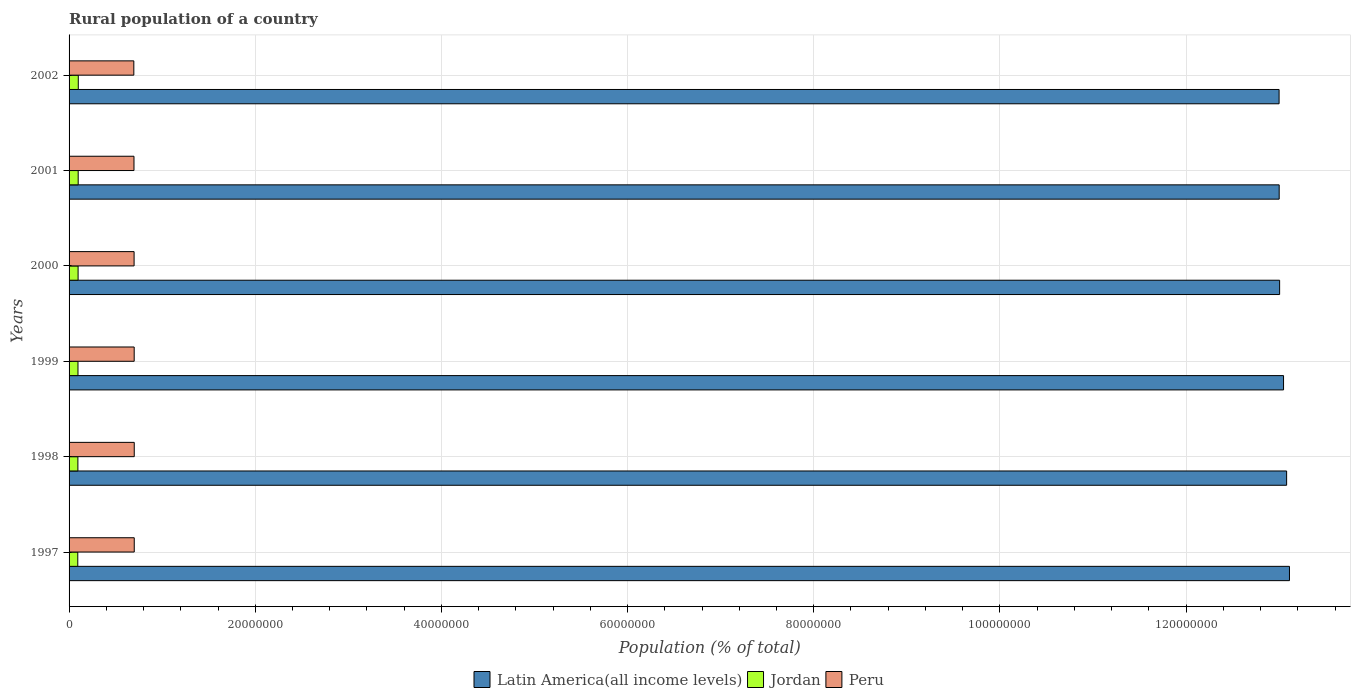How many different coloured bars are there?
Give a very brief answer. 3. How many groups of bars are there?
Make the answer very short. 6. Are the number of bars per tick equal to the number of legend labels?
Provide a short and direct response. Yes. Are the number of bars on each tick of the Y-axis equal?
Your response must be concise. Yes. How many bars are there on the 4th tick from the top?
Give a very brief answer. 3. What is the label of the 1st group of bars from the top?
Offer a very short reply. 2002. What is the rural population in Latin America(all income levels) in 1998?
Your answer should be very brief. 1.31e+08. Across all years, what is the maximum rural population in Jordan?
Provide a short and direct response. 9.89e+05. Across all years, what is the minimum rural population in Jordan?
Your answer should be compact. 9.35e+05. In which year was the rural population in Jordan maximum?
Provide a short and direct response. 2002. What is the total rural population in Peru in the graph?
Your answer should be compact. 4.19e+07. What is the difference between the rural population in Peru in 1997 and that in 2002?
Ensure brevity in your answer.  4.55e+04. What is the difference between the rural population in Jordan in 2000 and the rural population in Latin America(all income levels) in 1999?
Your answer should be very brief. -1.30e+08. What is the average rural population in Peru per year?
Ensure brevity in your answer.  6.99e+06. In the year 1998, what is the difference between the rural population in Peru and rural population in Jordan?
Provide a short and direct response. 6.05e+06. What is the ratio of the rural population in Peru in 1998 to that in 1999?
Keep it short and to the point. 1. Is the rural population in Peru in 1999 less than that in 2000?
Your answer should be compact. No. Is the difference between the rural population in Peru in 2001 and 2002 greater than the difference between the rural population in Jordan in 2001 and 2002?
Provide a succinct answer. Yes. What is the difference between the highest and the second highest rural population in Peru?
Provide a short and direct response. 329. What is the difference between the highest and the lowest rural population in Jordan?
Keep it short and to the point. 5.38e+04. What does the 3rd bar from the top in 2000 represents?
Offer a very short reply. Latin America(all income levels). What does the 2nd bar from the bottom in 1998 represents?
Keep it short and to the point. Jordan. Is it the case that in every year, the sum of the rural population in Peru and rural population in Jordan is greater than the rural population in Latin America(all income levels)?
Give a very brief answer. No. How many bars are there?
Your answer should be compact. 18. What is the difference between two consecutive major ticks on the X-axis?
Ensure brevity in your answer.  2.00e+07. Are the values on the major ticks of X-axis written in scientific E-notation?
Make the answer very short. No. Does the graph contain any zero values?
Offer a terse response. No. Does the graph contain grids?
Offer a very short reply. Yes. Where does the legend appear in the graph?
Ensure brevity in your answer.  Bottom center. What is the title of the graph?
Your response must be concise. Rural population of a country. Does "Portugal" appear as one of the legend labels in the graph?
Provide a succinct answer. No. What is the label or title of the X-axis?
Keep it short and to the point. Population (% of total). What is the Population (% of total) in Latin America(all income levels) in 1997?
Provide a short and direct response. 1.31e+08. What is the Population (% of total) of Jordan in 1997?
Ensure brevity in your answer.  9.35e+05. What is the Population (% of total) of Peru in 1997?
Provide a short and direct response. 7.00e+06. What is the Population (% of total) of Latin America(all income levels) in 1998?
Your answer should be very brief. 1.31e+08. What is the Population (% of total) in Jordan in 1998?
Provide a short and direct response. 9.48e+05. What is the Population (% of total) in Peru in 1998?
Offer a terse response. 7.00e+06. What is the Population (% of total) of Latin America(all income levels) in 1999?
Provide a short and direct response. 1.30e+08. What is the Population (% of total) in Jordan in 1999?
Offer a terse response. 9.58e+05. What is the Population (% of total) in Peru in 1999?
Provide a succinct answer. 7.00e+06. What is the Population (% of total) in Latin America(all income levels) in 2000?
Make the answer very short. 1.30e+08. What is the Population (% of total) of Jordan in 2000?
Your answer should be very brief. 9.69e+05. What is the Population (% of total) of Peru in 2000?
Provide a succinct answer. 6.99e+06. What is the Population (% of total) in Latin America(all income levels) in 2001?
Offer a very short reply. 1.30e+08. What is the Population (% of total) of Jordan in 2001?
Provide a succinct answer. 9.79e+05. What is the Population (% of total) of Peru in 2001?
Your answer should be very brief. 6.97e+06. What is the Population (% of total) in Latin America(all income levels) in 2002?
Offer a very short reply. 1.30e+08. What is the Population (% of total) of Jordan in 2002?
Your answer should be very brief. 9.89e+05. What is the Population (% of total) of Peru in 2002?
Make the answer very short. 6.96e+06. Across all years, what is the maximum Population (% of total) of Latin America(all income levels)?
Provide a succinct answer. 1.31e+08. Across all years, what is the maximum Population (% of total) in Jordan?
Provide a short and direct response. 9.89e+05. Across all years, what is the maximum Population (% of total) in Peru?
Your answer should be compact. 7.00e+06. Across all years, what is the minimum Population (% of total) in Latin America(all income levels)?
Give a very brief answer. 1.30e+08. Across all years, what is the minimum Population (% of total) in Jordan?
Keep it short and to the point. 9.35e+05. Across all years, what is the minimum Population (% of total) of Peru?
Provide a short and direct response. 6.96e+06. What is the total Population (% of total) in Latin America(all income levels) in the graph?
Provide a succinct answer. 7.82e+08. What is the total Population (% of total) of Jordan in the graph?
Your response must be concise. 5.78e+06. What is the total Population (% of total) of Peru in the graph?
Your answer should be very brief. 4.19e+07. What is the difference between the Population (% of total) in Latin America(all income levels) in 1997 and that in 1998?
Provide a succinct answer. 3.06e+05. What is the difference between the Population (% of total) in Jordan in 1997 and that in 1998?
Offer a very short reply. -1.21e+04. What is the difference between the Population (% of total) of Peru in 1997 and that in 1998?
Provide a succinct answer. 329. What is the difference between the Population (% of total) in Latin America(all income levels) in 1997 and that in 1999?
Keep it short and to the point. 6.37e+05. What is the difference between the Population (% of total) in Jordan in 1997 and that in 1999?
Your answer should be compact. -2.28e+04. What is the difference between the Population (% of total) of Peru in 1997 and that in 1999?
Ensure brevity in your answer.  5955. What is the difference between the Population (% of total) in Latin America(all income levels) in 1997 and that in 2000?
Provide a short and direct response. 1.06e+06. What is the difference between the Population (% of total) of Jordan in 1997 and that in 2000?
Offer a very short reply. -3.32e+04. What is the difference between the Population (% of total) of Peru in 1997 and that in 2000?
Ensure brevity in your answer.  1.57e+04. What is the difference between the Population (% of total) of Latin America(all income levels) in 1997 and that in 2001?
Ensure brevity in your answer.  1.11e+06. What is the difference between the Population (% of total) in Jordan in 1997 and that in 2001?
Ensure brevity in your answer.  -4.37e+04. What is the difference between the Population (% of total) of Peru in 1997 and that in 2001?
Ensure brevity in your answer.  2.89e+04. What is the difference between the Population (% of total) in Latin America(all income levels) in 1997 and that in 2002?
Your answer should be compact. 1.11e+06. What is the difference between the Population (% of total) in Jordan in 1997 and that in 2002?
Ensure brevity in your answer.  -5.38e+04. What is the difference between the Population (% of total) in Peru in 1997 and that in 2002?
Offer a terse response. 4.55e+04. What is the difference between the Population (% of total) in Latin America(all income levels) in 1998 and that in 1999?
Provide a succinct answer. 3.31e+05. What is the difference between the Population (% of total) of Jordan in 1998 and that in 1999?
Your response must be concise. -1.07e+04. What is the difference between the Population (% of total) of Peru in 1998 and that in 1999?
Make the answer very short. 5626. What is the difference between the Population (% of total) in Latin America(all income levels) in 1998 and that in 2000?
Your answer should be very brief. 7.51e+05. What is the difference between the Population (% of total) in Jordan in 1998 and that in 2000?
Provide a short and direct response. -2.11e+04. What is the difference between the Population (% of total) in Peru in 1998 and that in 2000?
Provide a short and direct response. 1.54e+04. What is the difference between the Population (% of total) of Latin America(all income levels) in 1998 and that in 2001?
Keep it short and to the point. 7.99e+05. What is the difference between the Population (% of total) of Jordan in 1998 and that in 2001?
Your answer should be compact. -3.16e+04. What is the difference between the Population (% of total) of Peru in 1998 and that in 2001?
Your response must be concise. 2.86e+04. What is the difference between the Population (% of total) in Latin America(all income levels) in 1998 and that in 2002?
Your answer should be very brief. 8.08e+05. What is the difference between the Population (% of total) in Jordan in 1998 and that in 2002?
Your response must be concise. -4.17e+04. What is the difference between the Population (% of total) of Peru in 1998 and that in 2002?
Keep it short and to the point. 4.52e+04. What is the difference between the Population (% of total) of Latin America(all income levels) in 1999 and that in 2000?
Keep it short and to the point. 4.21e+05. What is the difference between the Population (% of total) in Jordan in 1999 and that in 2000?
Keep it short and to the point. -1.04e+04. What is the difference between the Population (% of total) in Peru in 1999 and that in 2000?
Make the answer very short. 9739. What is the difference between the Population (% of total) of Latin America(all income levels) in 1999 and that in 2001?
Your answer should be very brief. 4.69e+05. What is the difference between the Population (% of total) of Jordan in 1999 and that in 2001?
Provide a short and direct response. -2.09e+04. What is the difference between the Population (% of total) of Peru in 1999 and that in 2001?
Provide a succinct answer. 2.30e+04. What is the difference between the Population (% of total) in Latin America(all income levels) in 1999 and that in 2002?
Offer a very short reply. 4.78e+05. What is the difference between the Population (% of total) in Jordan in 1999 and that in 2002?
Provide a short and direct response. -3.10e+04. What is the difference between the Population (% of total) of Peru in 1999 and that in 2002?
Provide a succinct answer. 3.96e+04. What is the difference between the Population (% of total) in Latin America(all income levels) in 2000 and that in 2001?
Keep it short and to the point. 4.79e+04. What is the difference between the Population (% of total) of Jordan in 2000 and that in 2001?
Ensure brevity in your answer.  -1.05e+04. What is the difference between the Population (% of total) of Peru in 2000 and that in 2001?
Your response must be concise. 1.32e+04. What is the difference between the Population (% of total) in Latin America(all income levels) in 2000 and that in 2002?
Your answer should be compact. 5.70e+04. What is the difference between the Population (% of total) in Jordan in 2000 and that in 2002?
Offer a very short reply. -2.07e+04. What is the difference between the Population (% of total) of Peru in 2000 and that in 2002?
Ensure brevity in your answer.  2.98e+04. What is the difference between the Population (% of total) of Latin America(all income levels) in 2001 and that in 2002?
Offer a very short reply. 9068. What is the difference between the Population (% of total) in Jordan in 2001 and that in 2002?
Offer a very short reply. -1.01e+04. What is the difference between the Population (% of total) of Peru in 2001 and that in 2002?
Your answer should be compact. 1.66e+04. What is the difference between the Population (% of total) of Latin America(all income levels) in 1997 and the Population (% of total) of Jordan in 1998?
Ensure brevity in your answer.  1.30e+08. What is the difference between the Population (% of total) of Latin America(all income levels) in 1997 and the Population (% of total) of Peru in 1998?
Keep it short and to the point. 1.24e+08. What is the difference between the Population (% of total) of Jordan in 1997 and the Population (% of total) of Peru in 1998?
Your response must be concise. -6.07e+06. What is the difference between the Population (% of total) in Latin America(all income levels) in 1997 and the Population (% of total) in Jordan in 1999?
Provide a short and direct response. 1.30e+08. What is the difference between the Population (% of total) of Latin America(all income levels) in 1997 and the Population (% of total) of Peru in 1999?
Keep it short and to the point. 1.24e+08. What is the difference between the Population (% of total) of Jordan in 1997 and the Population (% of total) of Peru in 1999?
Make the answer very short. -6.06e+06. What is the difference between the Population (% of total) of Latin America(all income levels) in 1997 and the Population (% of total) of Jordan in 2000?
Provide a succinct answer. 1.30e+08. What is the difference between the Population (% of total) in Latin America(all income levels) in 1997 and the Population (% of total) in Peru in 2000?
Offer a terse response. 1.24e+08. What is the difference between the Population (% of total) of Jordan in 1997 and the Population (% of total) of Peru in 2000?
Offer a very short reply. -6.05e+06. What is the difference between the Population (% of total) in Latin America(all income levels) in 1997 and the Population (% of total) in Jordan in 2001?
Your answer should be very brief. 1.30e+08. What is the difference between the Population (% of total) of Latin America(all income levels) in 1997 and the Population (% of total) of Peru in 2001?
Give a very brief answer. 1.24e+08. What is the difference between the Population (% of total) of Jordan in 1997 and the Population (% of total) of Peru in 2001?
Offer a very short reply. -6.04e+06. What is the difference between the Population (% of total) of Latin America(all income levels) in 1997 and the Population (% of total) of Jordan in 2002?
Provide a succinct answer. 1.30e+08. What is the difference between the Population (% of total) in Latin America(all income levels) in 1997 and the Population (% of total) in Peru in 2002?
Provide a succinct answer. 1.24e+08. What is the difference between the Population (% of total) of Jordan in 1997 and the Population (% of total) of Peru in 2002?
Provide a succinct answer. -6.02e+06. What is the difference between the Population (% of total) of Latin America(all income levels) in 1998 and the Population (% of total) of Jordan in 1999?
Your answer should be very brief. 1.30e+08. What is the difference between the Population (% of total) in Latin America(all income levels) in 1998 and the Population (% of total) in Peru in 1999?
Provide a short and direct response. 1.24e+08. What is the difference between the Population (% of total) in Jordan in 1998 and the Population (% of total) in Peru in 1999?
Ensure brevity in your answer.  -6.05e+06. What is the difference between the Population (% of total) in Latin America(all income levels) in 1998 and the Population (% of total) in Jordan in 2000?
Provide a short and direct response. 1.30e+08. What is the difference between the Population (% of total) in Latin America(all income levels) in 1998 and the Population (% of total) in Peru in 2000?
Your response must be concise. 1.24e+08. What is the difference between the Population (% of total) in Jordan in 1998 and the Population (% of total) in Peru in 2000?
Your answer should be compact. -6.04e+06. What is the difference between the Population (% of total) in Latin America(all income levels) in 1998 and the Population (% of total) in Jordan in 2001?
Make the answer very short. 1.30e+08. What is the difference between the Population (% of total) of Latin America(all income levels) in 1998 and the Population (% of total) of Peru in 2001?
Ensure brevity in your answer.  1.24e+08. What is the difference between the Population (% of total) in Jordan in 1998 and the Population (% of total) in Peru in 2001?
Make the answer very short. -6.03e+06. What is the difference between the Population (% of total) in Latin America(all income levels) in 1998 and the Population (% of total) in Jordan in 2002?
Offer a very short reply. 1.30e+08. What is the difference between the Population (% of total) in Latin America(all income levels) in 1998 and the Population (% of total) in Peru in 2002?
Provide a succinct answer. 1.24e+08. What is the difference between the Population (% of total) of Jordan in 1998 and the Population (% of total) of Peru in 2002?
Your answer should be very brief. -6.01e+06. What is the difference between the Population (% of total) of Latin America(all income levels) in 1999 and the Population (% of total) of Jordan in 2000?
Offer a very short reply. 1.30e+08. What is the difference between the Population (% of total) of Latin America(all income levels) in 1999 and the Population (% of total) of Peru in 2000?
Ensure brevity in your answer.  1.23e+08. What is the difference between the Population (% of total) of Jordan in 1999 and the Population (% of total) of Peru in 2000?
Offer a very short reply. -6.03e+06. What is the difference between the Population (% of total) in Latin America(all income levels) in 1999 and the Population (% of total) in Jordan in 2001?
Your answer should be very brief. 1.29e+08. What is the difference between the Population (% of total) of Latin America(all income levels) in 1999 and the Population (% of total) of Peru in 2001?
Offer a terse response. 1.23e+08. What is the difference between the Population (% of total) in Jordan in 1999 and the Population (% of total) in Peru in 2001?
Provide a short and direct response. -6.01e+06. What is the difference between the Population (% of total) of Latin America(all income levels) in 1999 and the Population (% of total) of Jordan in 2002?
Your answer should be compact. 1.29e+08. What is the difference between the Population (% of total) of Latin America(all income levels) in 1999 and the Population (% of total) of Peru in 2002?
Your answer should be very brief. 1.24e+08. What is the difference between the Population (% of total) in Jordan in 1999 and the Population (% of total) in Peru in 2002?
Give a very brief answer. -6.00e+06. What is the difference between the Population (% of total) in Latin America(all income levels) in 2000 and the Population (% of total) in Jordan in 2001?
Ensure brevity in your answer.  1.29e+08. What is the difference between the Population (% of total) of Latin America(all income levels) in 2000 and the Population (% of total) of Peru in 2001?
Keep it short and to the point. 1.23e+08. What is the difference between the Population (% of total) in Jordan in 2000 and the Population (% of total) in Peru in 2001?
Ensure brevity in your answer.  -6.00e+06. What is the difference between the Population (% of total) of Latin America(all income levels) in 2000 and the Population (% of total) of Jordan in 2002?
Give a very brief answer. 1.29e+08. What is the difference between the Population (% of total) of Latin America(all income levels) in 2000 and the Population (% of total) of Peru in 2002?
Offer a terse response. 1.23e+08. What is the difference between the Population (% of total) in Jordan in 2000 and the Population (% of total) in Peru in 2002?
Provide a succinct answer. -5.99e+06. What is the difference between the Population (% of total) in Latin America(all income levels) in 2001 and the Population (% of total) in Jordan in 2002?
Provide a short and direct response. 1.29e+08. What is the difference between the Population (% of total) in Latin America(all income levels) in 2001 and the Population (% of total) in Peru in 2002?
Ensure brevity in your answer.  1.23e+08. What is the difference between the Population (% of total) of Jordan in 2001 and the Population (% of total) of Peru in 2002?
Make the answer very short. -5.98e+06. What is the average Population (% of total) in Latin America(all income levels) per year?
Keep it short and to the point. 1.30e+08. What is the average Population (% of total) in Jordan per year?
Your answer should be very brief. 9.63e+05. What is the average Population (% of total) of Peru per year?
Keep it short and to the point. 6.99e+06. In the year 1997, what is the difference between the Population (% of total) of Latin America(all income levels) and Population (% of total) of Jordan?
Offer a terse response. 1.30e+08. In the year 1997, what is the difference between the Population (% of total) in Latin America(all income levels) and Population (% of total) in Peru?
Your response must be concise. 1.24e+08. In the year 1997, what is the difference between the Population (% of total) of Jordan and Population (% of total) of Peru?
Your response must be concise. -6.07e+06. In the year 1998, what is the difference between the Population (% of total) in Latin America(all income levels) and Population (% of total) in Jordan?
Offer a terse response. 1.30e+08. In the year 1998, what is the difference between the Population (% of total) of Latin America(all income levels) and Population (% of total) of Peru?
Make the answer very short. 1.24e+08. In the year 1998, what is the difference between the Population (% of total) in Jordan and Population (% of total) in Peru?
Your response must be concise. -6.05e+06. In the year 1999, what is the difference between the Population (% of total) in Latin America(all income levels) and Population (% of total) in Jordan?
Provide a succinct answer. 1.30e+08. In the year 1999, what is the difference between the Population (% of total) in Latin America(all income levels) and Population (% of total) in Peru?
Give a very brief answer. 1.23e+08. In the year 1999, what is the difference between the Population (% of total) in Jordan and Population (% of total) in Peru?
Keep it short and to the point. -6.04e+06. In the year 2000, what is the difference between the Population (% of total) of Latin America(all income levels) and Population (% of total) of Jordan?
Offer a terse response. 1.29e+08. In the year 2000, what is the difference between the Population (% of total) of Latin America(all income levels) and Population (% of total) of Peru?
Provide a short and direct response. 1.23e+08. In the year 2000, what is the difference between the Population (% of total) of Jordan and Population (% of total) of Peru?
Make the answer very short. -6.02e+06. In the year 2001, what is the difference between the Population (% of total) of Latin America(all income levels) and Population (% of total) of Jordan?
Your answer should be very brief. 1.29e+08. In the year 2001, what is the difference between the Population (% of total) of Latin America(all income levels) and Population (% of total) of Peru?
Offer a terse response. 1.23e+08. In the year 2001, what is the difference between the Population (% of total) of Jordan and Population (% of total) of Peru?
Keep it short and to the point. -5.99e+06. In the year 2002, what is the difference between the Population (% of total) in Latin America(all income levels) and Population (% of total) in Jordan?
Your response must be concise. 1.29e+08. In the year 2002, what is the difference between the Population (% of total) in Latin America(all income levels) and Population (% of total) in Peru?
Keep it short and to the point. 1.23e+08. In the year 2002, what is the difference between the Population (% of total) of Jordan and Population (% of total) of Peru?
Provide a short and direct response. -5.97e+06. What is the ratio of the Population (% of total) in Jordan in 1997 to that in 1998?
Give a very brief answer. 0.99. What is the ratio of the Population (% of total) of Peru in 1997 to that in 1998?
Give a very brief answer. 1. What is the ratio of the Population (% of total) of Latin America(all income levels) in 1997 to that in 1999?
Keep it short and to the point. 1. What is the ratio of the Population (% of total) of Jordan in 1997 to that in 1999?
Your answer should be compact. 0.98. What is the ratio of the Population (% of total) of Peru in 1997 to that in 1999?
Give a very brief answer. 1. What is the ratio of the Population (% of total) in Jordan in 1997 to that in 2000?
Provide a succinct answer. 0.97. What is the ratio of the Population (% of total) in Latin America(all income levels) in 1997 to that in 2001?
Offer a very short reply. 1.01. What is the ratio of the Population (% of total) of Jordan in 1997 to that in 2001?
Your answer should be very brief. 0.96. What is the ratio of the Population (% of total) of Peru in 1997 to that in 2001?
Your answer should be very brief. 1. What is the ratio of the Population (% of total) of Latin America(all income levels) in 1997 to that in 2002?
Your response must be concise. 1.01. What is the ratio of the Population (% of total) in Jordan in 1997 to that in 2002?
Offer a very short reply. 0.95. What is the ratio of the Population (% of total) of Peru in 1998 to that in 1999?
Give a very brief answer. 1. What is the ratio of the Population (% of total) of Jordan in 1998 to that in 2000?
Your answer should be compact. 0.98. What is the ratio of the Population (% of total) in Peru in 1998 to that in 2000?
Your answer should be compact. 1. What is the ratio of the Population (% of total) in Jordan in 1998 to that in 2001?
Make the answer very short. 0.97. What is the ratio of the Population (% of total) of Latin America(all income levels) in 1998 to that in 2002?
Offer a terse response. 1.01. What is the ratio of the Population (% of total) in Jordan in 1998 to that in 2002?
Offer a very short reply. 0.96. What is the ratio of the Population (% of total) in Latin America(all income levels) in 1999 to that in 2000?
Offer a terse response. 1. What is the ratio of the Population (% of total) in Jordan in 1999 to that in 2000?
Provide a short and direct response. 0.99. What is the ratio of the Population (% of total) of Jordan in 1999 to that in 2001?
Your answer should be compact. 0.98. What is the ratio of the Population (% of total) in Peru in 1999 to that in 2001?
Provide a short and direct response. 1. What is the ratio of the Population (% of total) in Jordan in 1999 to that in 2002?
Ensure brevity in your answer.  0.97. What is the ratio of the Population (% of total) in Peru in 1999 to that in 2002?
Provide a succinct answer. 1.01. What is the ratio of the Population (% of total) in Jordan in 2000 to that in 2001?
Keep it short and to the point. 0.99. What is the ratio of the Population (% of total) of Jordan in 2000 to that in 2002?
Ensure brevity in your answer.  0.98. What is the ratio of the Population (% of total) in Jordan in 2001 to that in 2002?
Offer a terse response. 0.99. What is the difference between the highest and the second highest Population (% of total) in Latin America(all income levels)?
Ensure brevity in your answer.  3.06e+05. What is the difference between the highest and the second highest Population (% of total) in Jordan?
Give a very brief answer. 1.01e+04. What is the difference between the highest and the second highest Population (% of total) of Peru?
Give a very brief answer. 329. What is the difference between the highest and the lowest Population (% of total) in Latin America(all income levels)?
Provide a succinct answer. 1.11e+06. What is the difference between the highest and the lowest Population (% of total) in Jordan?
Provide a succinct answer. 5.38e+04. What is the difference between the highest and the lowest Population (% of total) in Peru?
Your answer should be compact. 4.55e+04. 